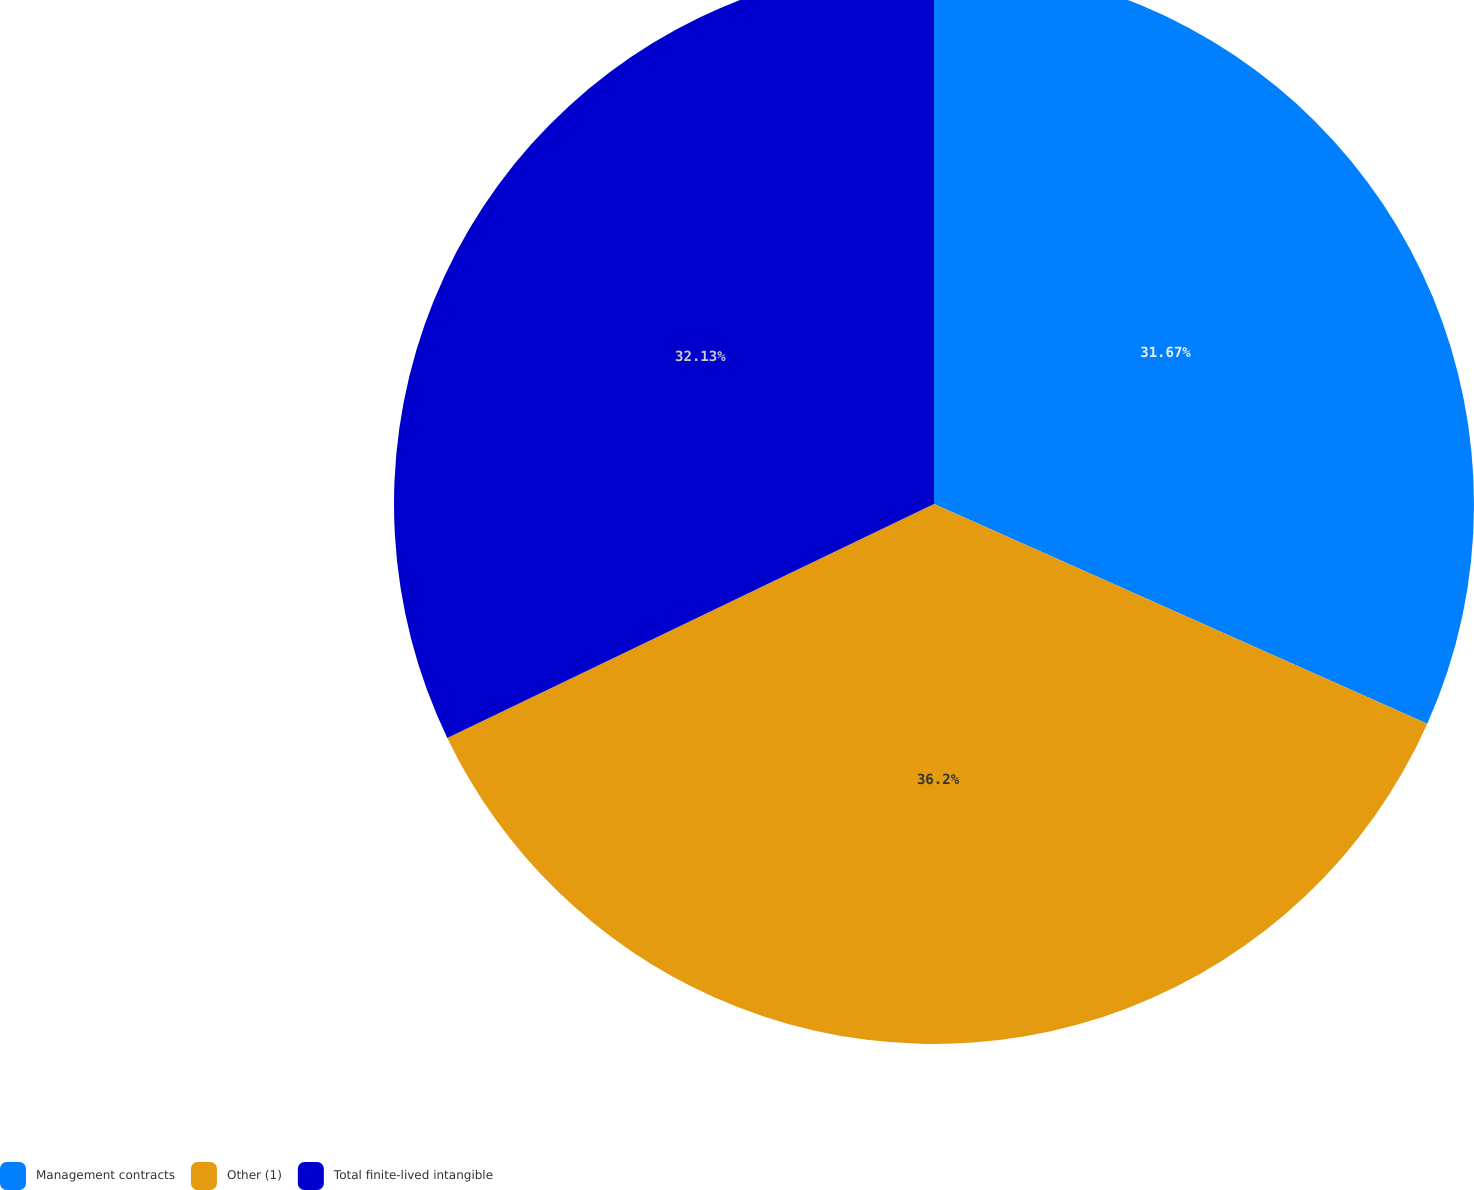Convert chart to OTSL. <chart><loc_0><loc_0><loc_500><loc_500><pie_chart><fcel>Management contracts<fcel>Other (1)<fcel>Total finite-lived intangible<nl><fcel>31.67%<fcel>36.2%<fcel>32.13%<nl></chart> 